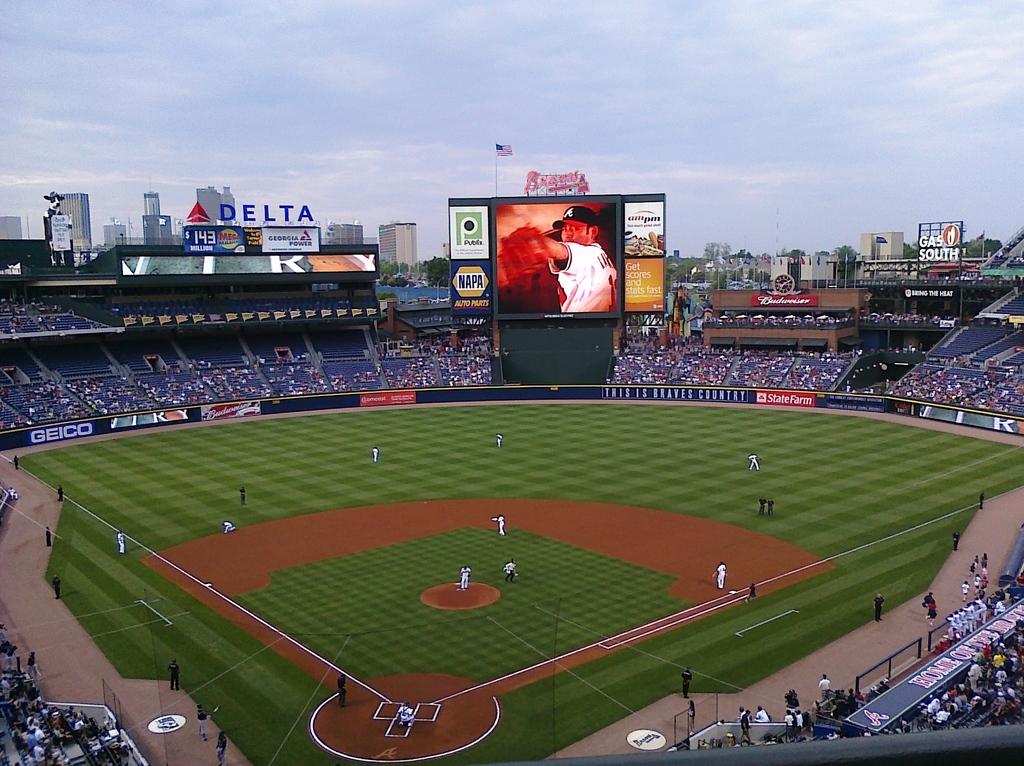What airline sponsors this stadium?
Your answer should be compact. Delta. What auto parts store is on the scoreboard?
Give a very brief answer. Napa. 